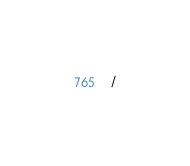<code> <loc_0><loc_0><loc_500><loc_500><_SQL_>/
</code> 